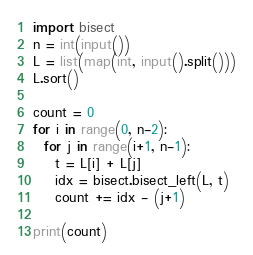<code> <loc_0><loc_0><loc_500><loc_500><_Python_>import bisect
n = int(input())
L = list(map(int, input().split()))
L.sort()

count = 0
for i in range(0, n-2):
  for j in range(i+1, n-1):
    t = L[i] + L[j]
    idx = bisect.bisect_left(L, t)
    count += idx - (j+1)

print(count)
</code> 